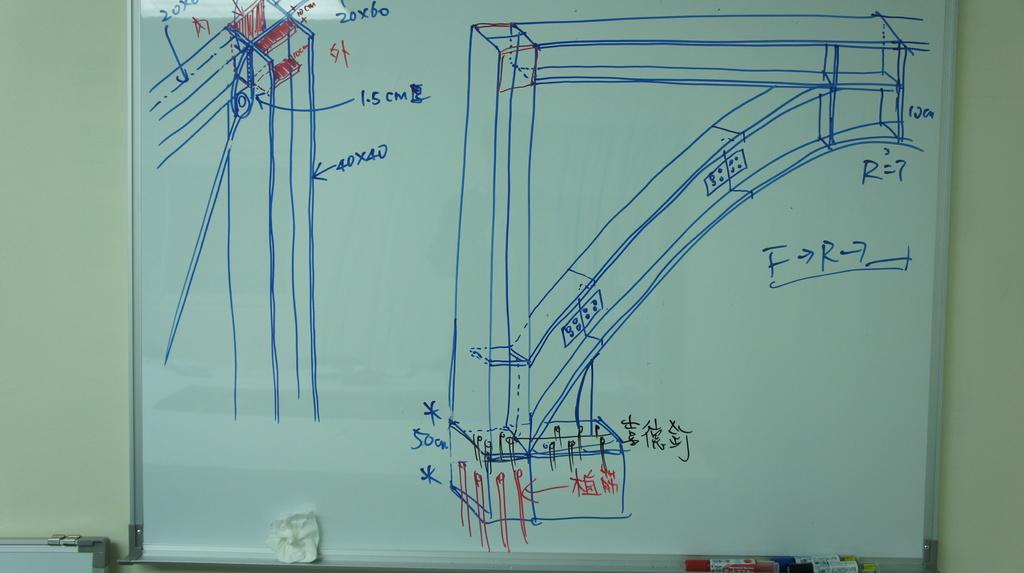<image>
Present a compact description of the photo's key features. A diagram for a building one of the pieces measures 40x40 